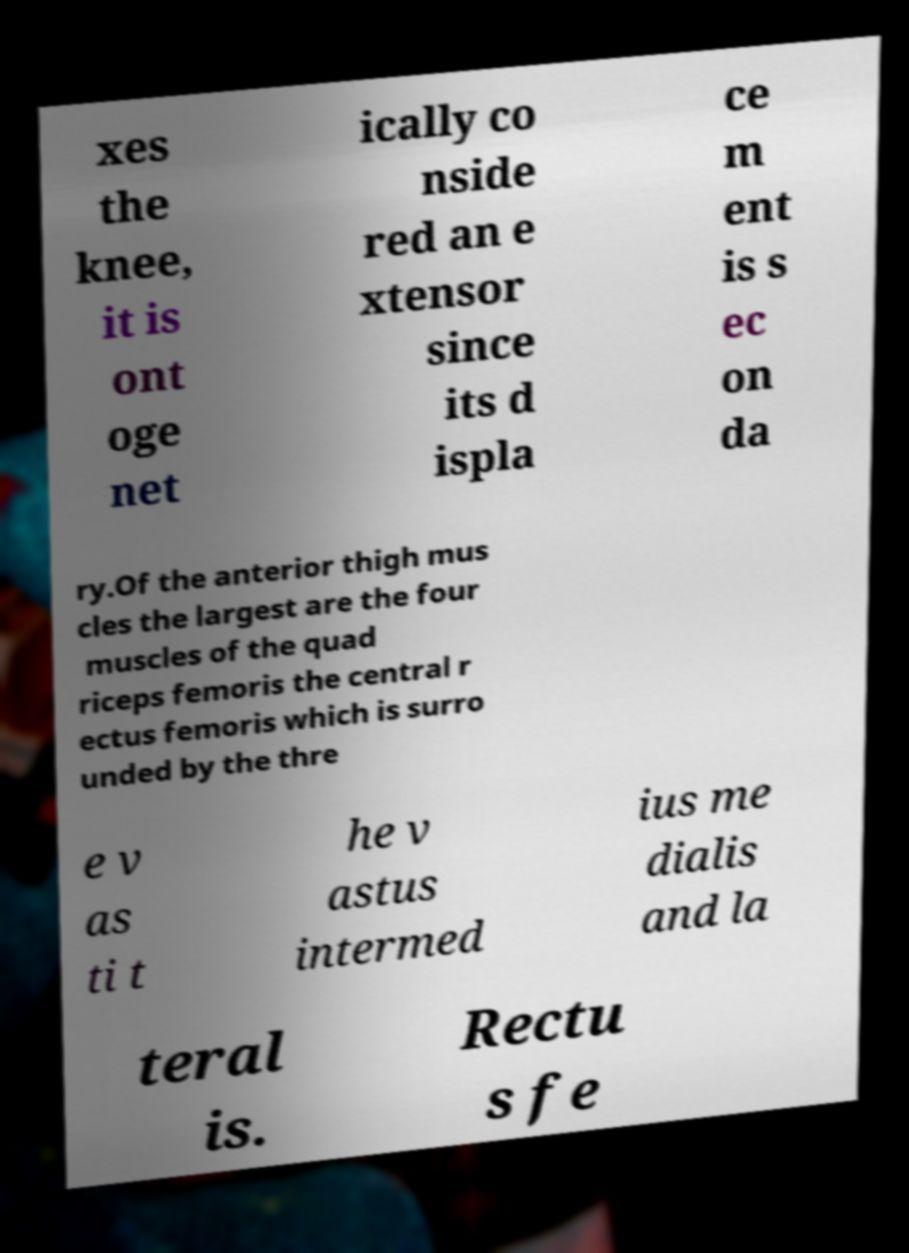Could you assist in decoding the text presented in this image and type it out clearly? xes the knee, it is ont oge net ically co nside red an e xtensor since its d ispla ce m ent is s ec on da ry.Of the anterior thigh mus cles the largest are the four muscles of the quad riceps femoris the central r ectus femoris which is surro unded by the thre e v as ti t he v astus intermed ius me dialis and la teral is. Rectu s fe 